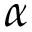Convert formula to latex. <formula><loc_0><loc_0><loc_500><loc_500>\alpha</formula> 